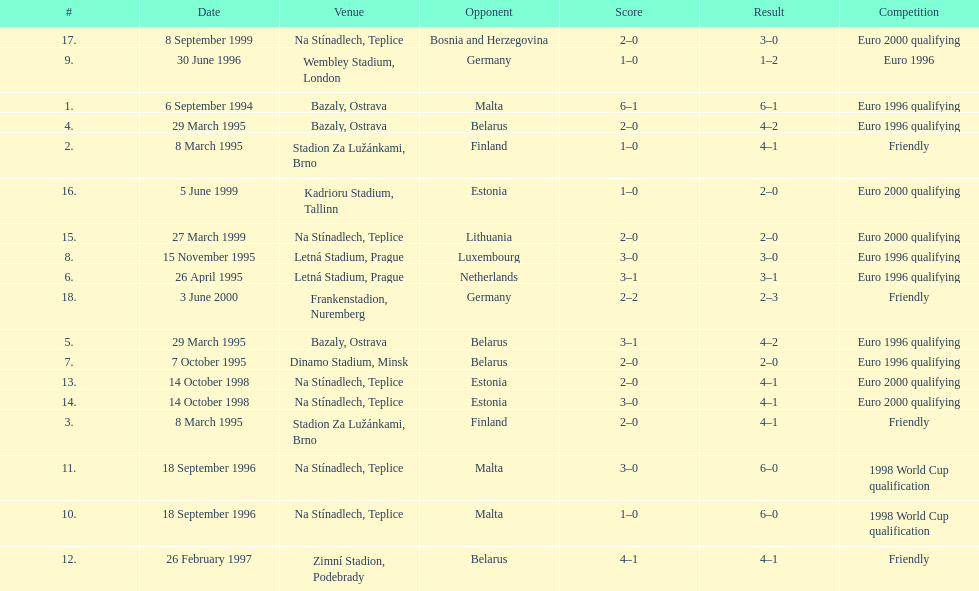List the opponents which are under the friendly competition. Finland, Belarus, Germany. 